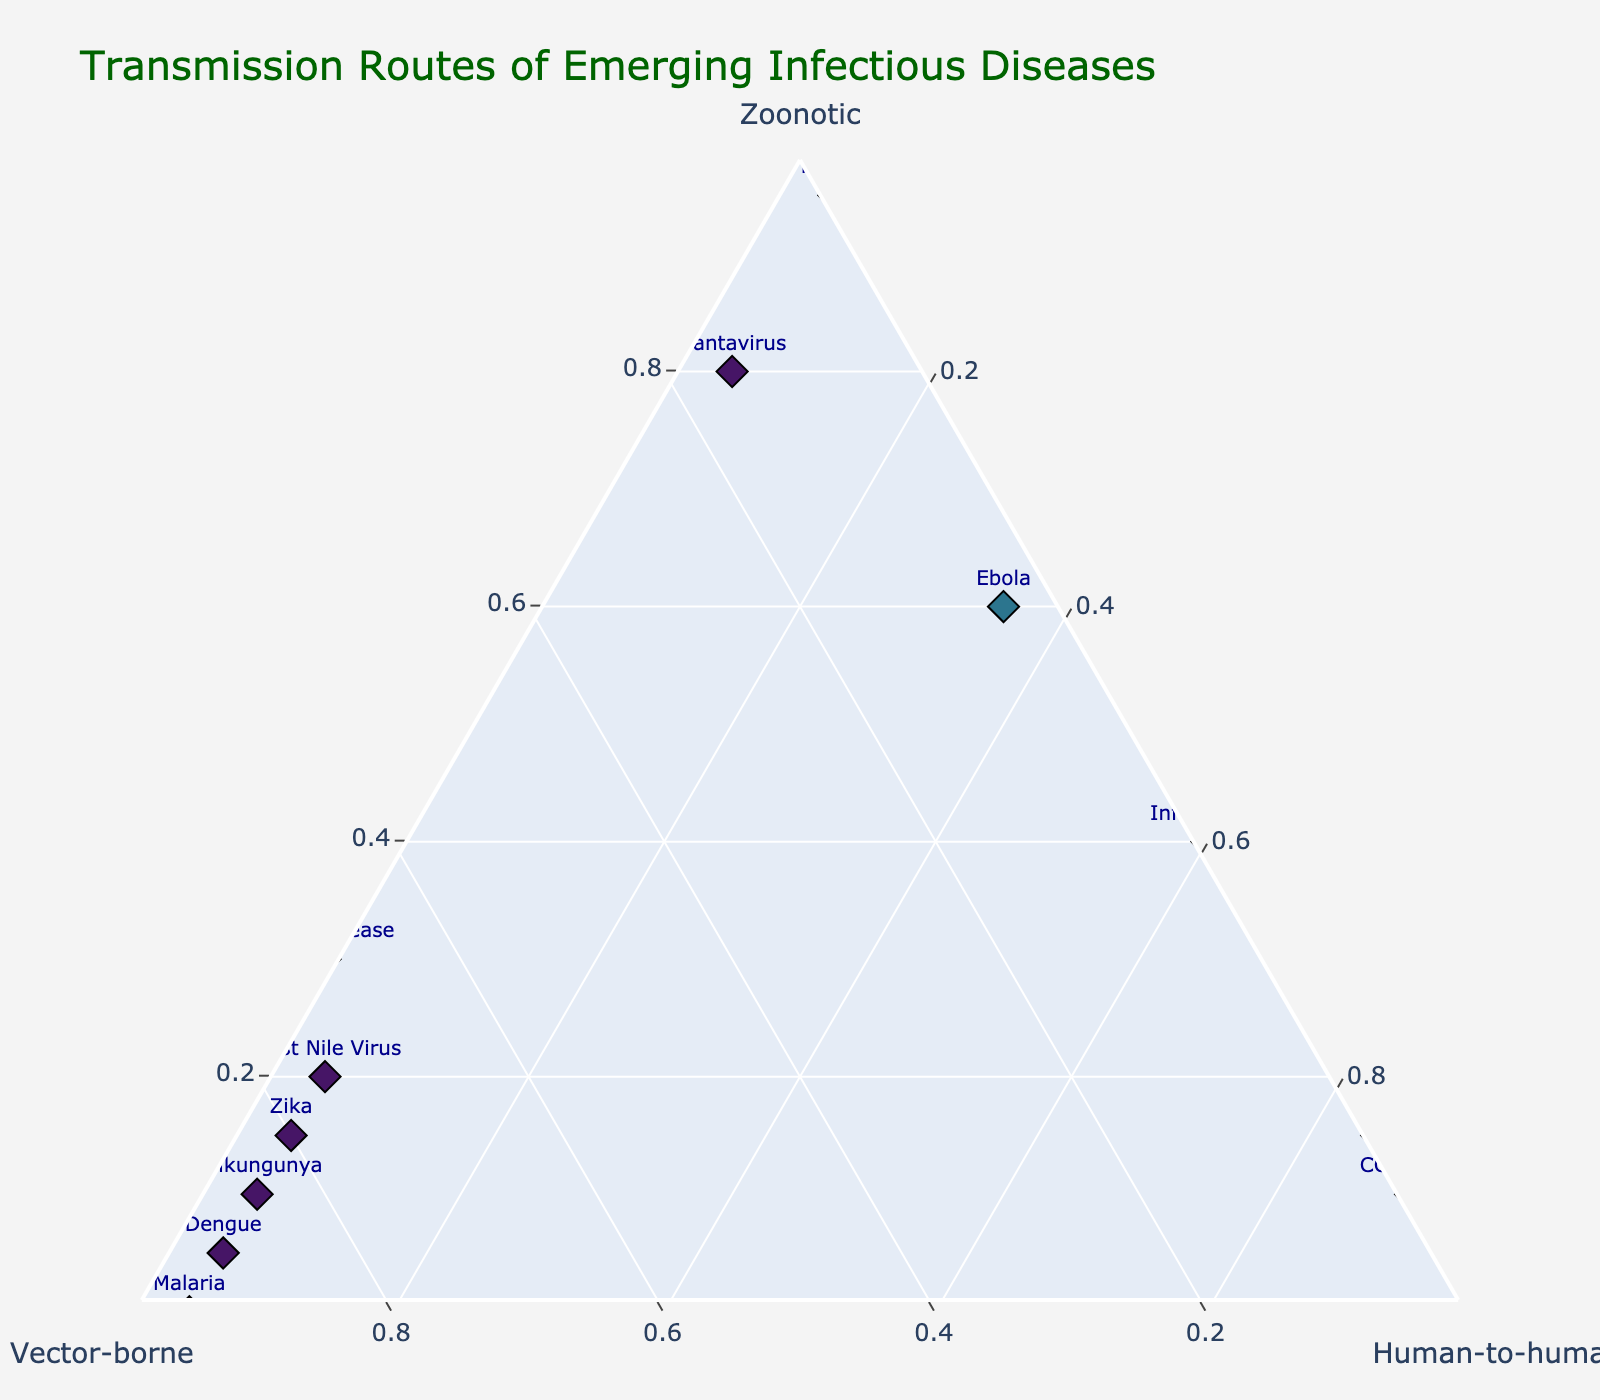What is the title of the figure? The title typically appears at the top of the figure and provides a summary of what the figure represents. Here, it is written in green font and clearly states the focus of the plot.
Answer: Transmission Routes of Emerging Infectious Diseases What axis represents the zoonotic transmission route? In a ternary plot, each vertex represents one of the variables. The plot axis is labeled with the titles 'Zoonotic', 'Vector-borne', and 'Human-to-human'. The 'Zoonotic' axis is labeled as such.
Answer: The left vertex Which disease has the highest proportion of human-to-human transmission? By looking at the plot, you can find the point closest to the 'Human-to-human' vertex. This point corresponds to the disease with the highest proportion of human-to-human transmission.
Answer: COVID-19 Which two diseases have the highest and lowest vector-borne transmission proportions? Identify the points closest and farthest from the 'Vector-borne' vertex. The disease closest to the 'Vector-borne' vertex has the highest proportion, and the one farthest away has the lowest.
Answer: Malaria has the highest, and Influenza A has the lowest What is the sum of the zoonotic and human-to-human proportions for Influenza A? Look at the data for Influenza A. Add up the zoonotic (0.40) and human-to-human (0.60) proportions.
Answer: 1.0 Which diseases are solely relying on vector-borne transmission within a margin of 5% human-to-human transmission? Find the points where the vector-borne proportion is high, and human-to-human proportion is precisely 0.05 or lower; these are close to the bottom-right vertex but within a marginal boundary.
Answer: Malaria and Zika How many diseases have at least an 80% zoonotic transmission route? Count the data points where the zoonotic transmission proportion is 0.80 or higher. In this case, distinguish diseases mainly relying on zoonotic routes.
Answer: Two (Hantavirus, Rabies) Compare the zoonotic proportion between Ebola and SARS. Which one is higher? Check the zoonotic values for both Ebola (0.60) and SARS (0.15) and compare them. Ebola has the higher zoonotic proportion.
Answer: Ebola What is the proportion difference for zoonotic transmission between Rabies and Lyme Disease? Look at the zoonotic proportions for Rabies (0.95) and Lyme Disease (0.30). Subtract the smaller value from the larger value to find the difference.
Answer: 0.65 Identify a disease with balanced proportions of vector-borne and human-to-human transmission. Look for a point where the proportions of vector-borne and human-to-human are similar or equal. The visual observation will guide you to the most balanced one.
Answer: None, all disease points are notably skewed 